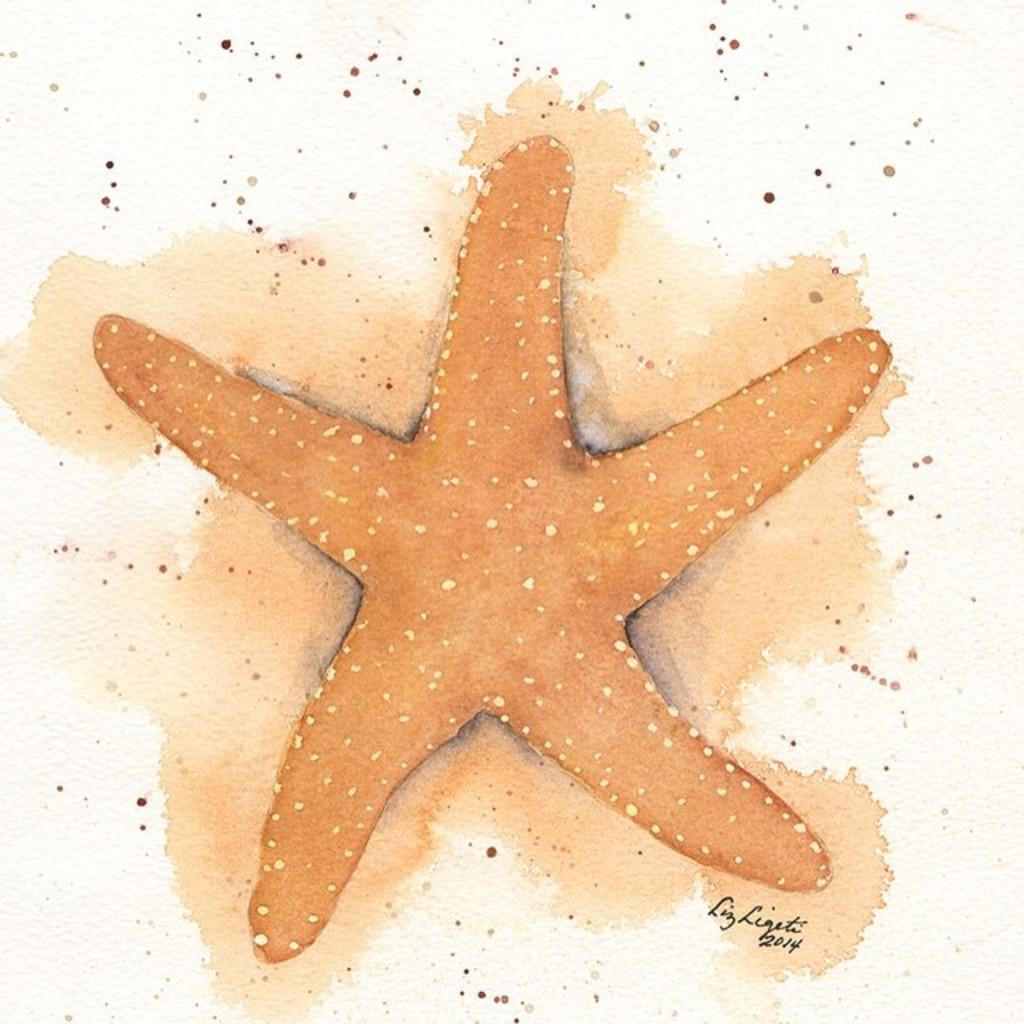In one or two sentences, can you explain what this image depicts? The picture is a painting. In the picture there is a starfish. At the bottom there is text. The background is white. There are red dots on the white background. 